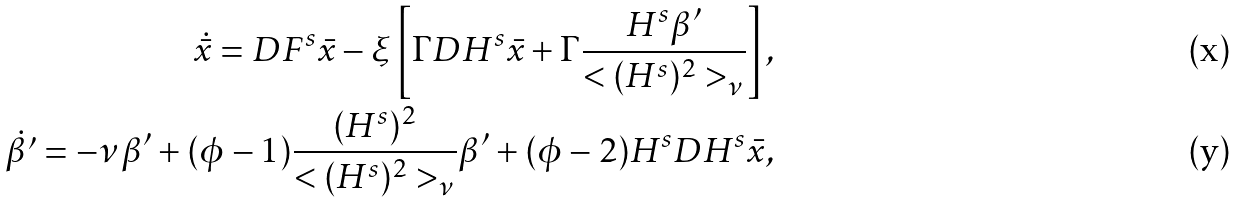<formula> <loc_0><loc_0><loc_500><loc_500>\dot { \bar { x } } = D F ^ { s } \bar { x } - \xi \left [ \Gamma D H ^ { s } \bar { x } + \Gamma \frac { H ^ { s } \beta ^ { \prime } } { < ( H ^ { s } ) ^ { 2 } > _ { \nu } } \right ] , \\ \dot { \beta ^ { \prime } } = - \nu \beta ^ { \prime } + ( \phi - 1 ) \frac { ( H ^ { s } ) ^ { 2 } } { < ( H ^ { s } ) ^ { 2 } > _ { \nu } } \beta ^ { \prime } + ( \phi - 2 ) H ^ { s } D H ^ { s } \bar { x } ,</formula> 